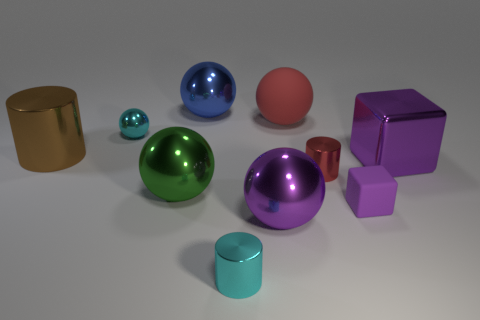There is a cyan object that is in front of the big brown shiny cylinder; what material is it?
Provide a succinct answer. Metal. There is a purple metal thing that is to the right of the rubber thing that is in front of the large shiny cube; what size is it?
Give a very brief answer. Large. How many brown cylinders are the same size as the metal block?
Offer a very short reply. 1. There is a cylinder on the right side of the large rubber object; is its color the same as the small object in front of the big purple sphere?
Your response must be concise. No. There is a large green metal sphere; are there any brown cylinders in front of it?
Your answer should be compact. No. What color is the tiny object that is behind the small block and on the right side of the big red matte sphere?
Your response must be concise. Red. Is there a big ball of the same color as the matte block?
Provide a short and direct response. Yes. Is the material of the thing that is behind the red sphere the same as the big thing that is to the right of the large red object?
Give a very brief answer. Yes. There is a metal cylinder in front of the small purple matte thing; what is its size?
Your answer should be compact. Small. How big is the cyan shiny cylinder?
Ensure brevity in your answer.  Small. 